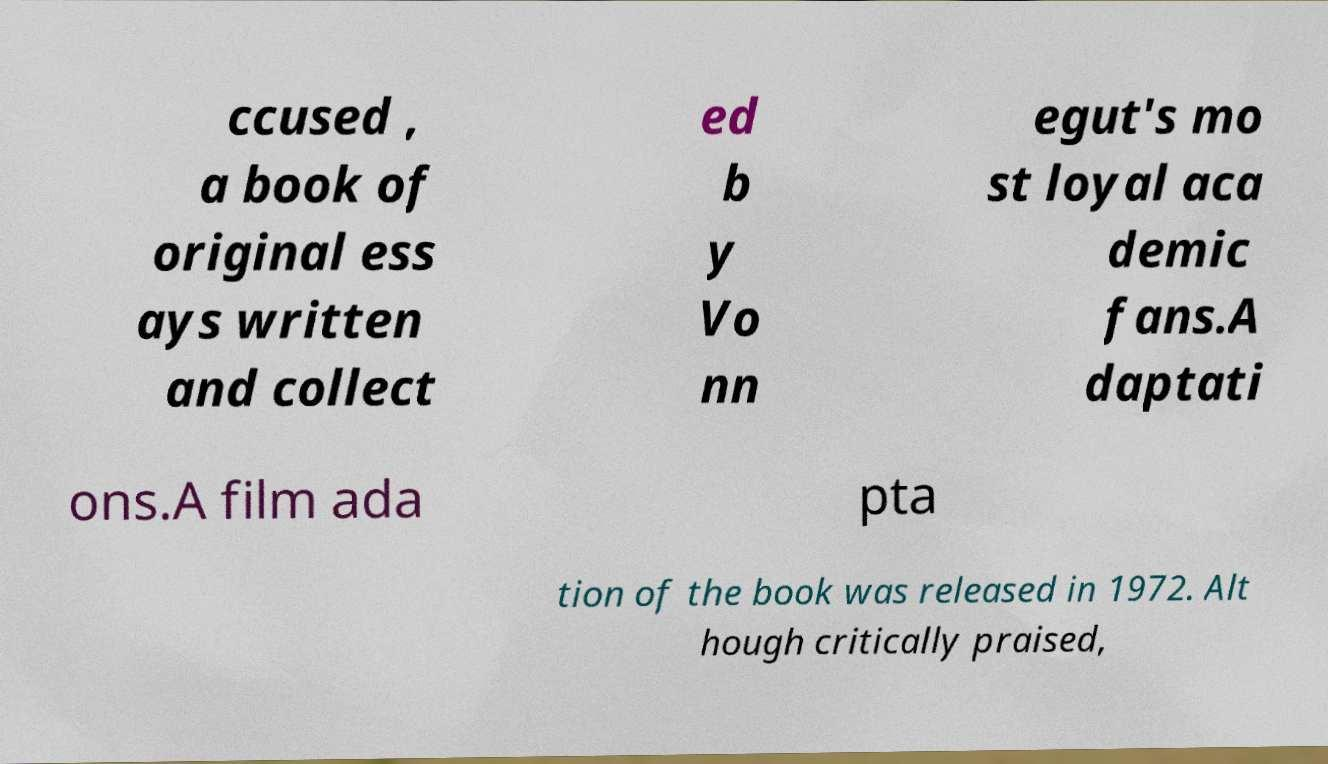For documentation purposes, I need the text within this image transcribed. Could you provide that? ccused , a book of original ess ays written and collect ed b y Vo nn egut's mo st loyal aca demic fans.A daptati ons.A film ada pta tion of the book was released in 1972. Alt hough critically praised, 